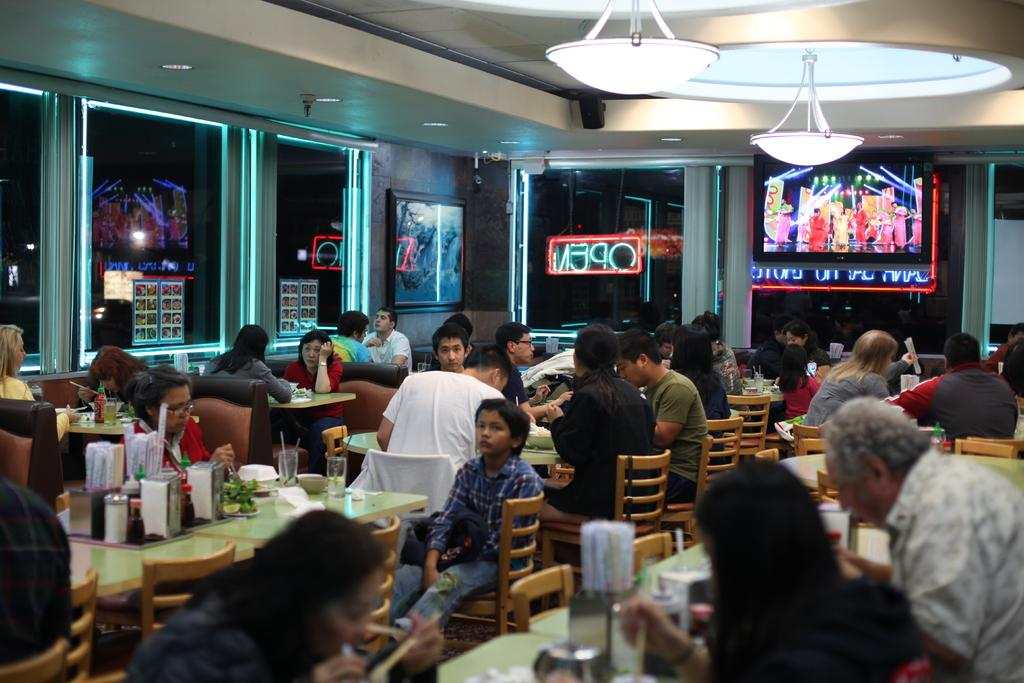What are the people in the image doing? The people in the image are sitting on chairs. What can be seen on the tables in the image? There are glasses, jars, and other objects on the tables. What is visible in the background of the image? There is a wall, a television, and glass windows in the background of the image. What can be seen at the top of the image? There are lights visible at the top of the image. What type of shoe is being invented in the image? There is no mention of a shoe or an invention in the image. 